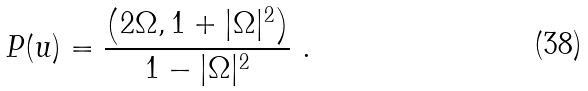<formula> <loc_0><loc_0><loc_500><loc_500>P ( u ) = \frac { \left ( 2 \Omega , 1 + | \Omega | ^ { 2 } \right ) } { 1 - | \Omega | ^ { 2 } } \ .</formula> 